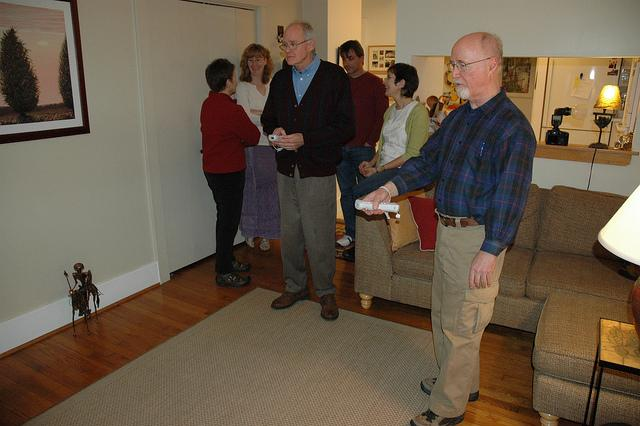Where have these people gathered? living room 